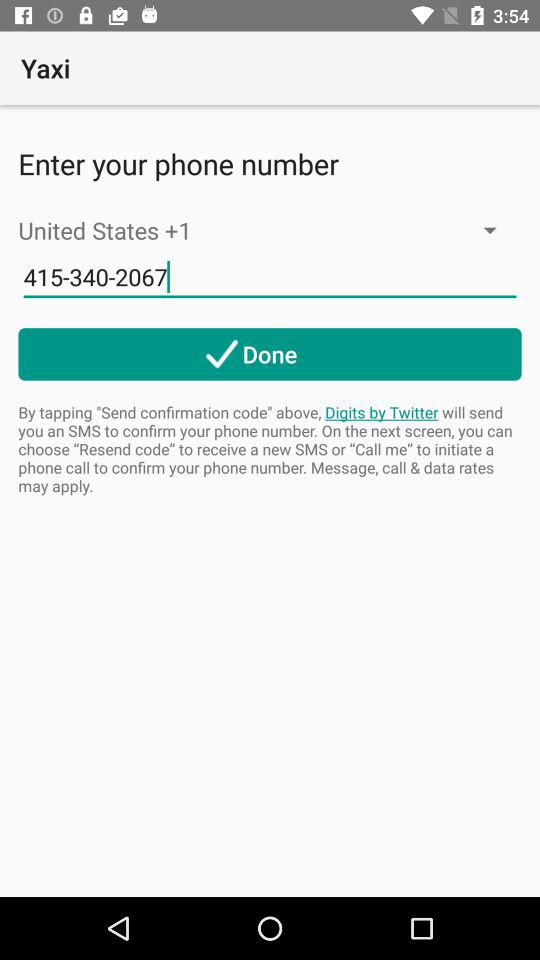On the screen, which country is displayed? The displayed country on the screen is the United States. 